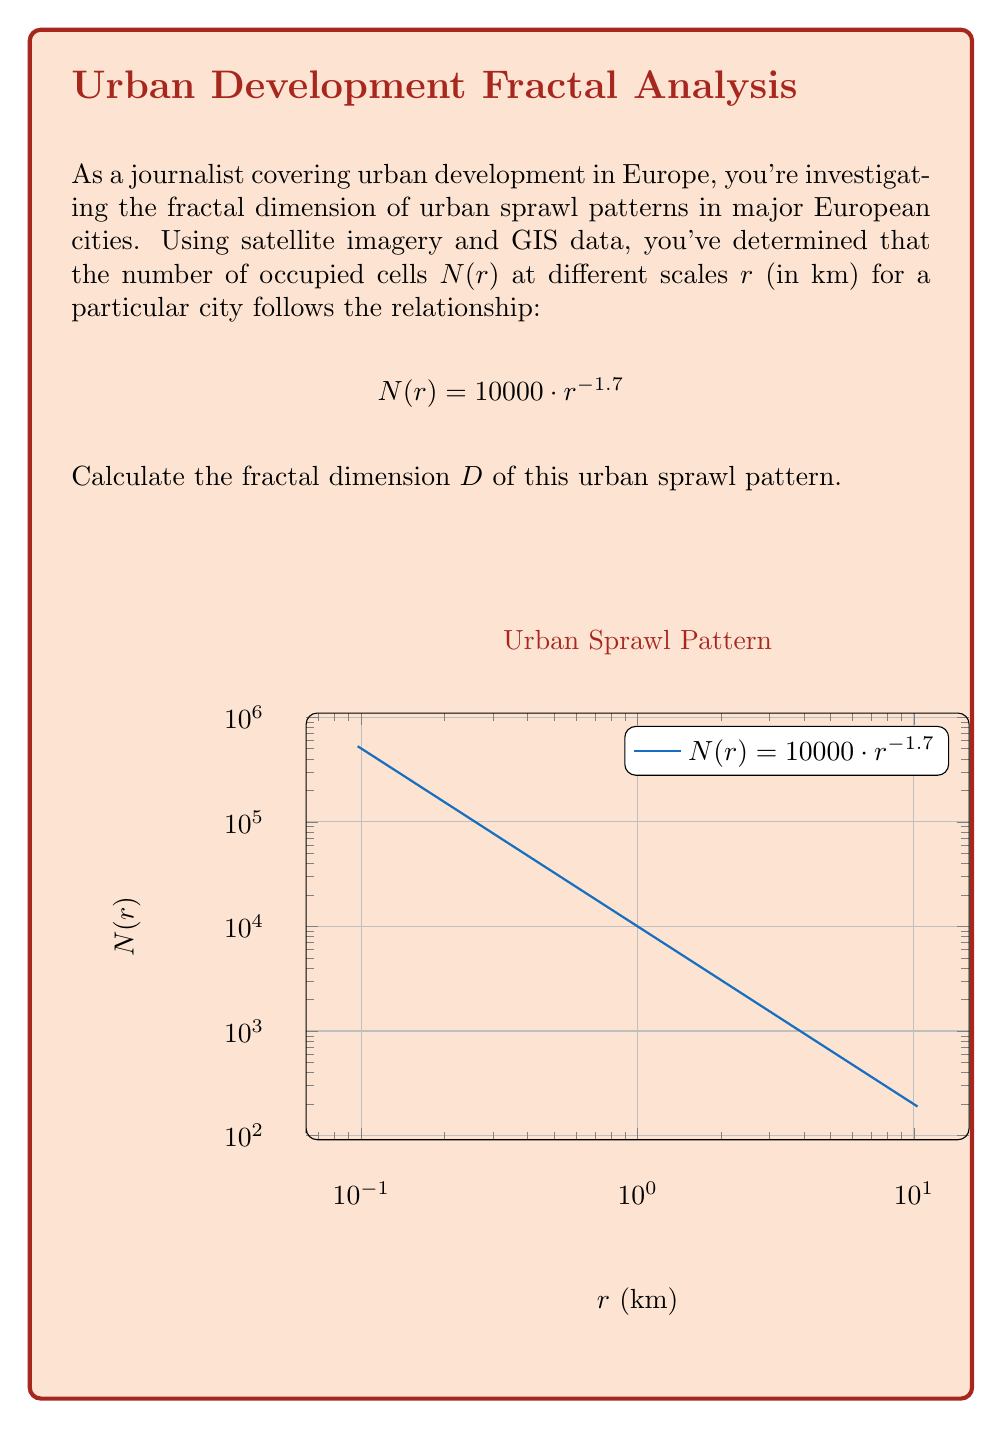Help me with this question. To calculate the fractal dimension $D$, we need to use the box-counting method, which relates to the power law relationship between the number of occupied cells $N(r)$ and the scale $r$:

$$N(r) \propto r^{-D}$$

Given:
$$N(r) = 10000 \cdot r^{-1.7}$$

Step 1: Identify the exponent in the given equation.
The exponent is $-1.7$.

Step 2: Relate the exponent to the fractal dimension $D$.
In the general form $N(r) \propto r^{-D}$, the exponent is $-D$.

Step 3: Equate the exponents.
$$-D = -1.7$$

Step 4: Solve for $D$.
$$D = 1.7$$

Therefore, the fractal dimension of the urban sprawl pattern is 1.7.

This value indicates that the urban sprawl pattern is more complex than a simple line (dimension 1) but less space-filling than a solid plane (dimension 2), which is typical for urban developments that show some degree of fragmentation and irregularity in their growth patterns.
Answer: $D = 1.7$ 